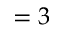<formula> <loc_0><loc_0><loc_500><loc_500>= 3</formula> 